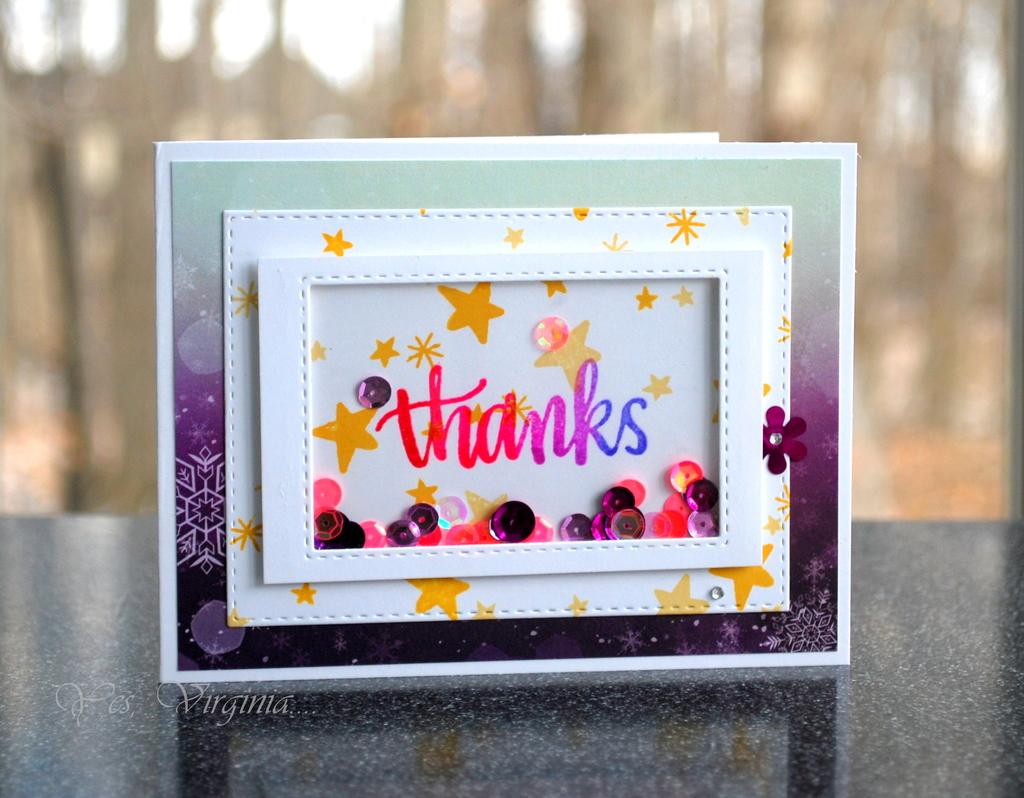<image>
Present a compact description of the photo's key features. A thank you card that says thanks and has stars on it. 